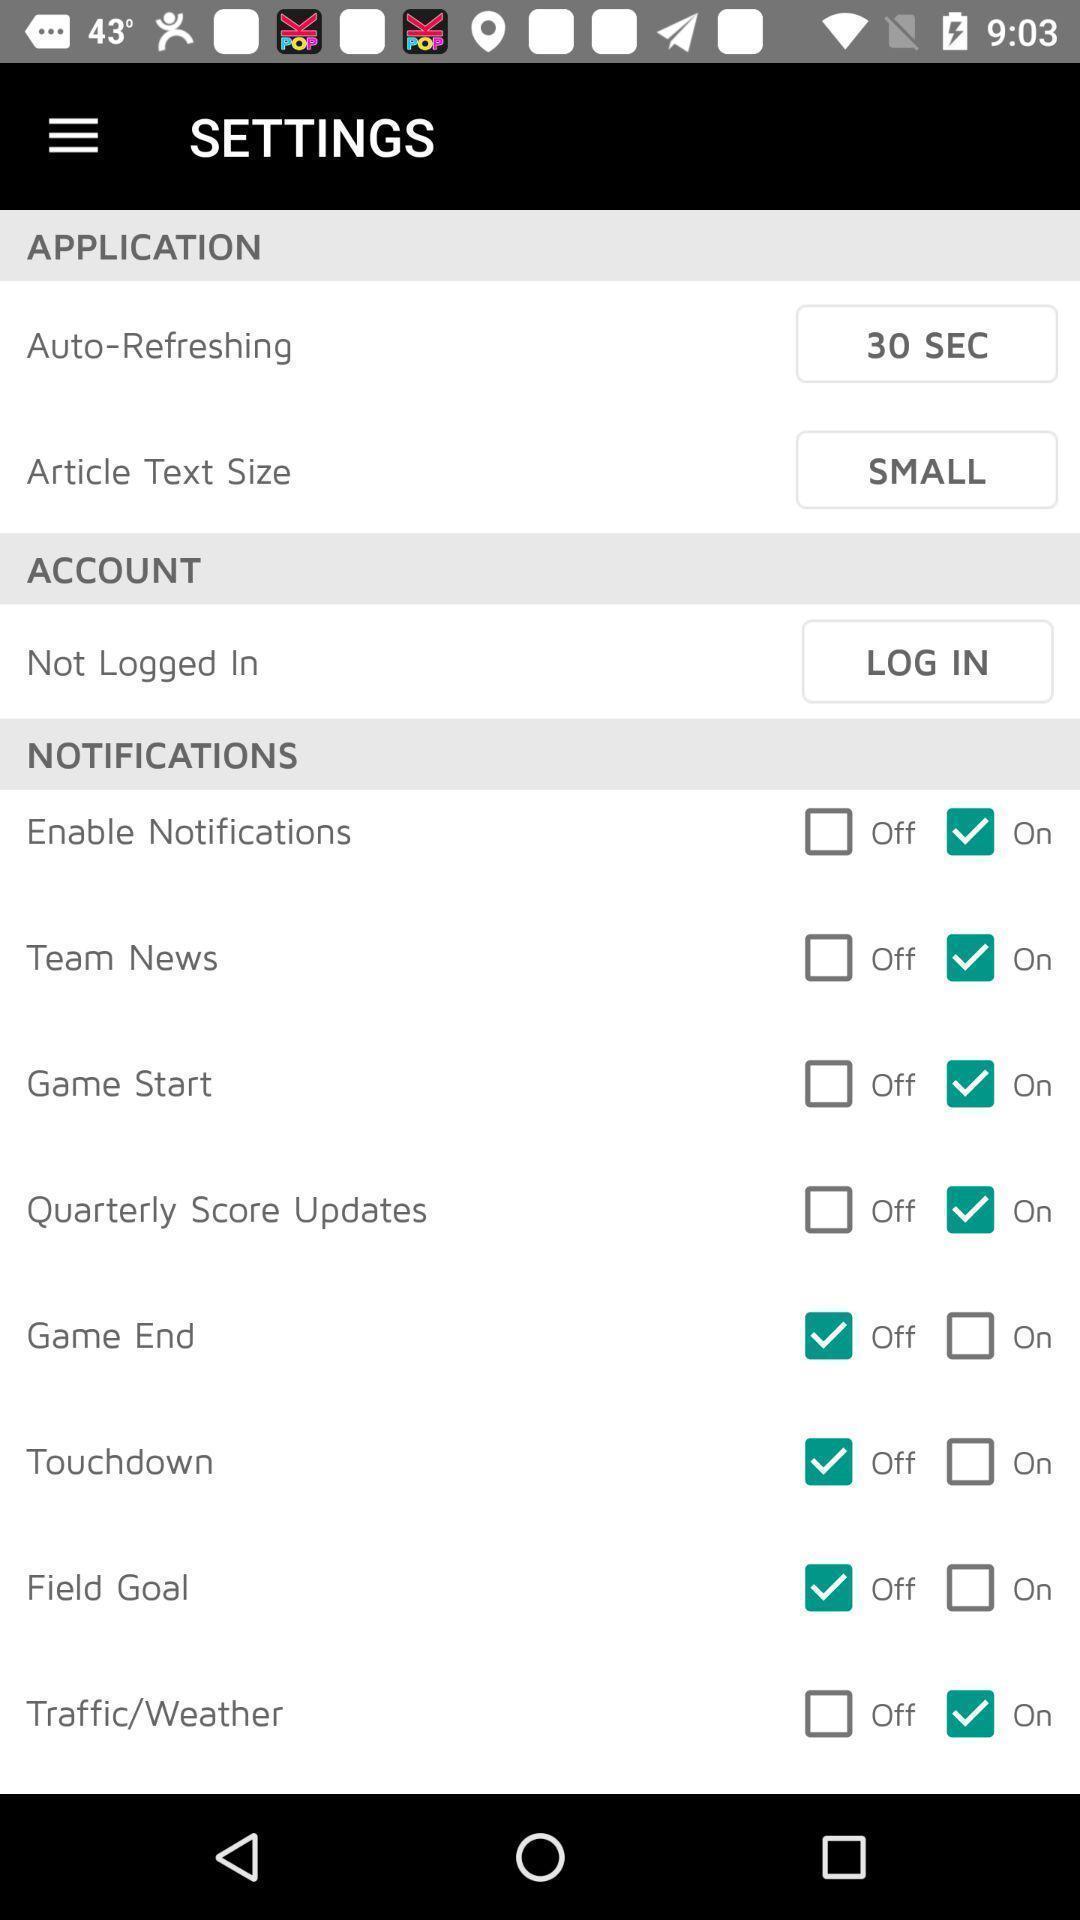Give me a narrative description of this picture. Settings tab with different options in the application. 